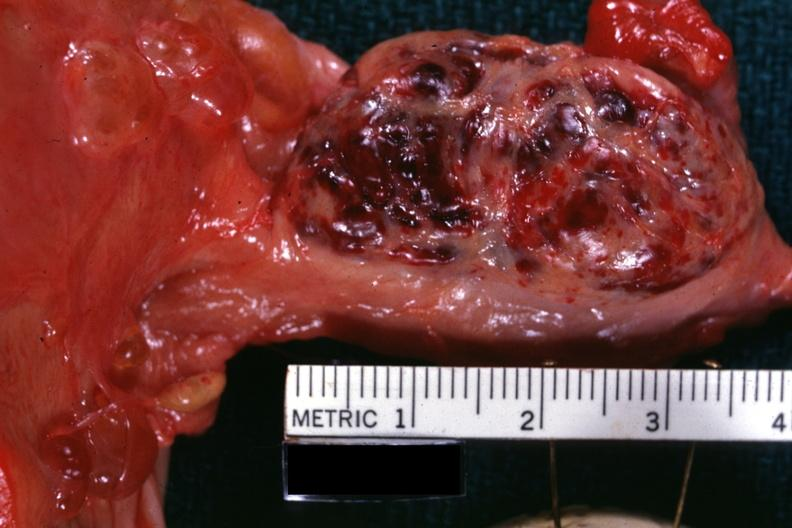where does this belong to?
Answer the question using a single word or phrase. Female reproductive system 